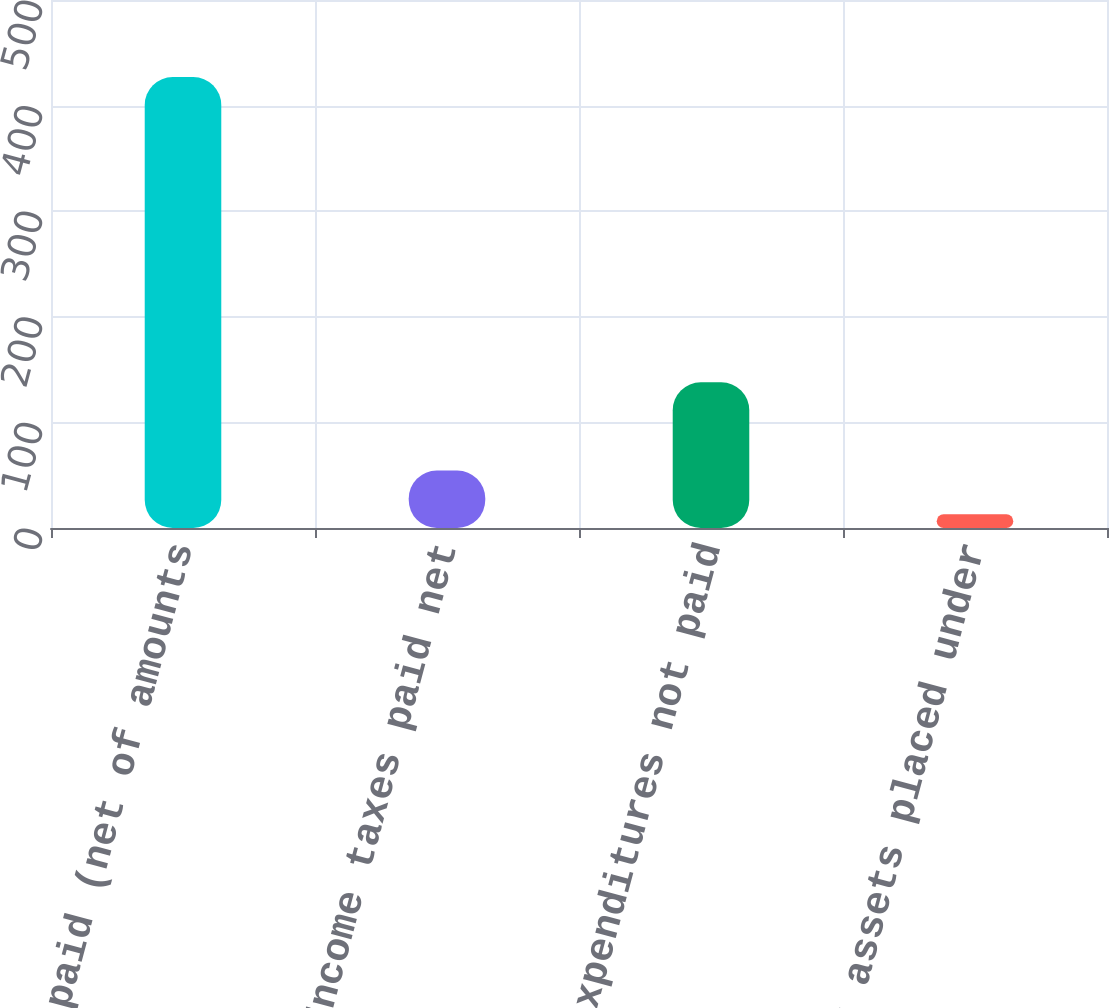Convert chart. <chart><loc_0><loc_0><loc_500><loc_500><bar_chart><fcel>Interest paid (net of amounts<fcel>Income taxes paid net<fcel>Capital expenditures not paid<fcel>Other assets placed under<nl><fcel>427<fcel>54.4<fcel>138<fcel>13<nl></chart> 